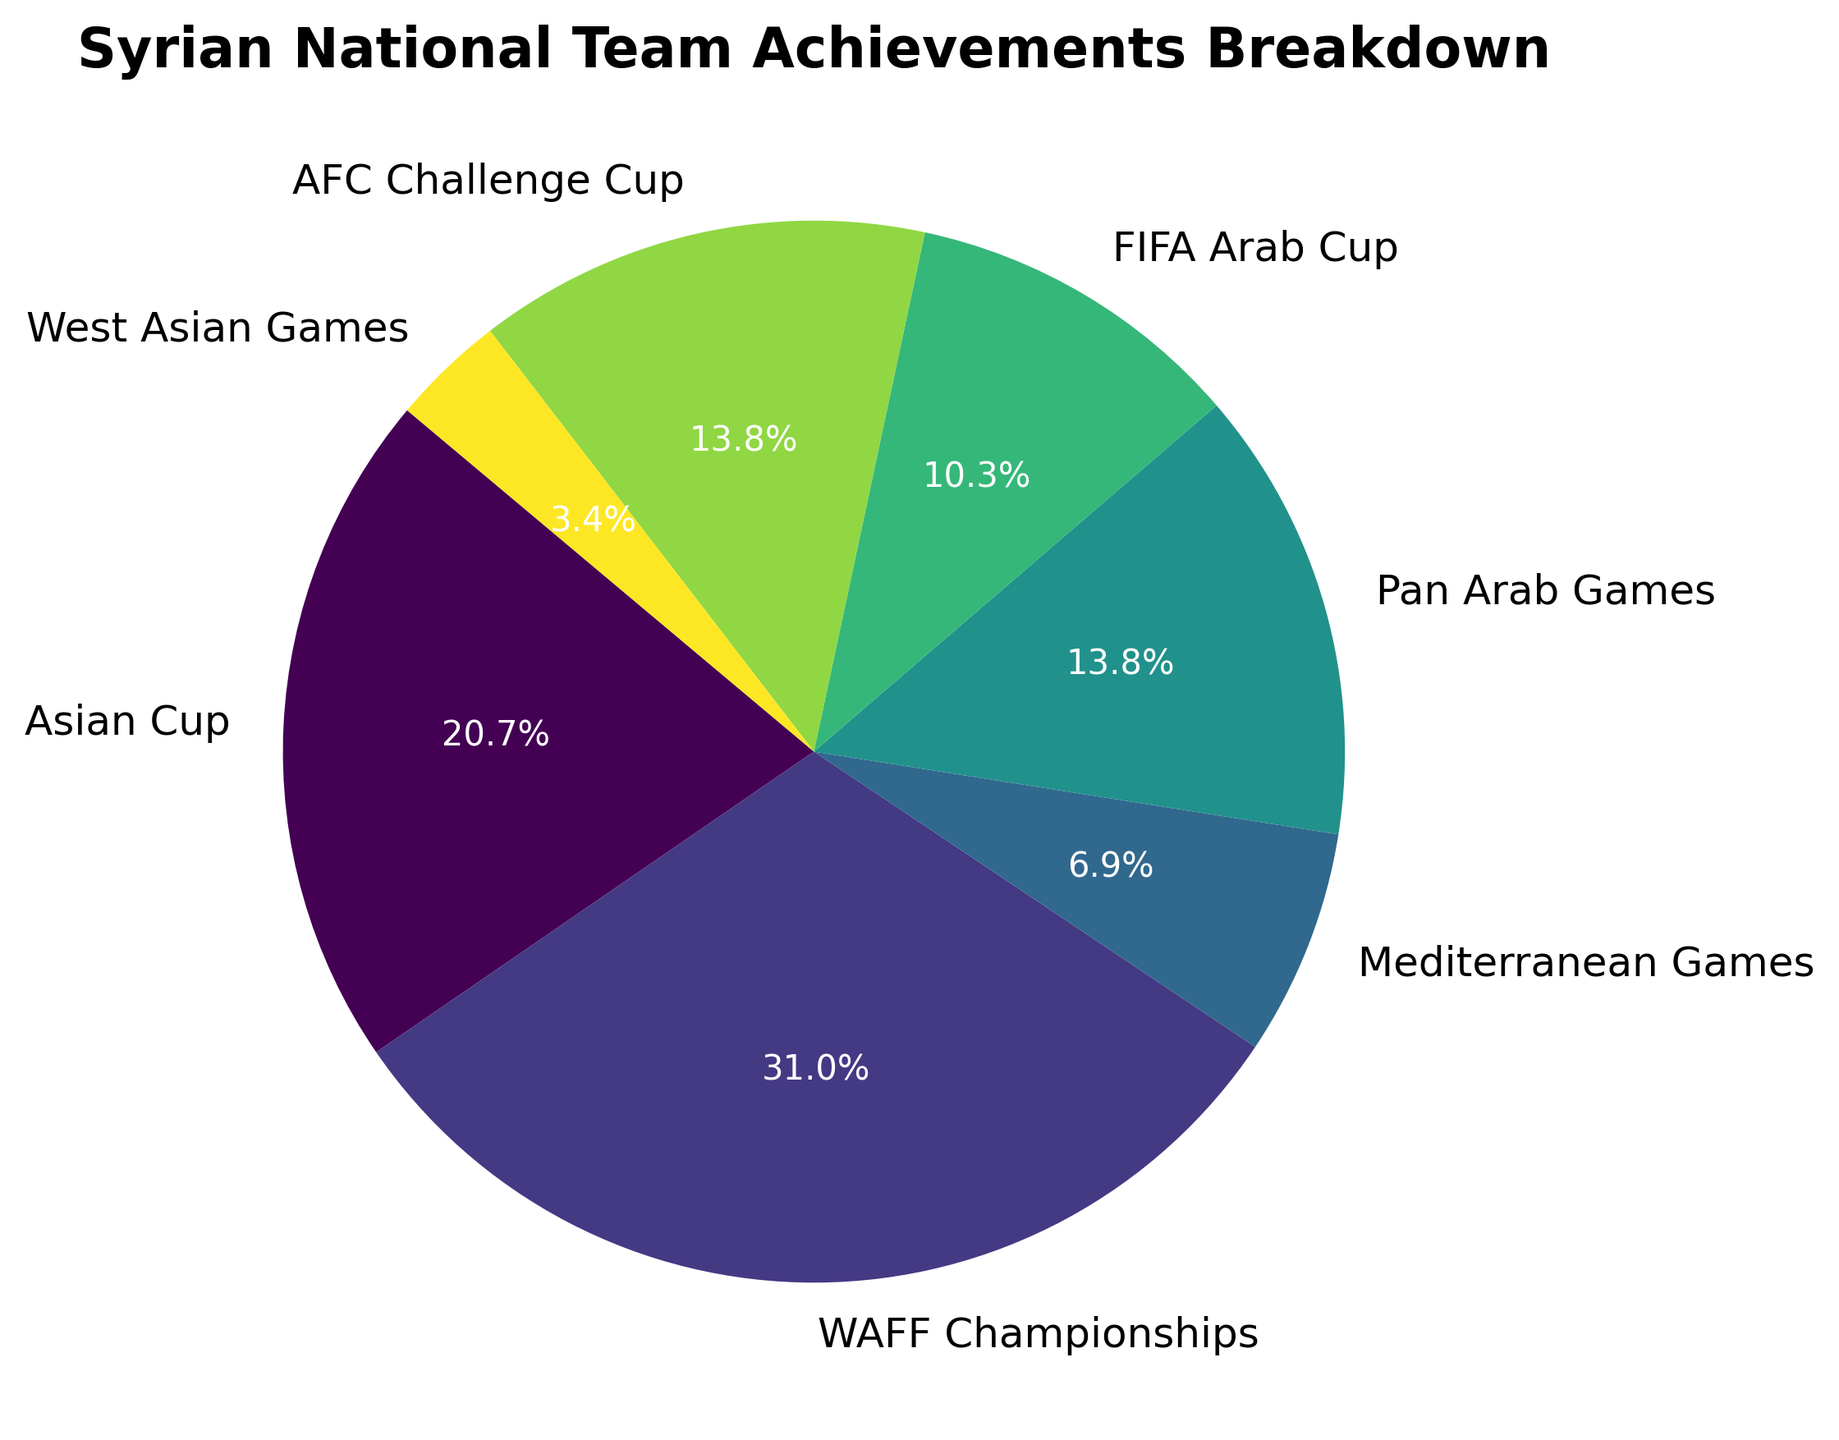Which achievement has the highest percentage of occurrences? To determine the achievement with the highest percentage, we look at the divisions in the pie chart and identify the segment with the largest area. Since the WAFF Championships Participations had nine instances, it is the largest.
Answer: WAFF Championships How many total participations are shown across all achievements? To find the total participation count, add the number of occurrences for each participation category shown in the pie chart. WAFF Championships (9) + Asian Cup (6) + Pan Arab Games (4) + FIFA Arab Cup (3) + AFC Challenge Cup (4) + Mediterranean Games (2) + West Asian Games (1). The total is 29.
Answer: 29 Which achievement has a smaller percentage of occurrences: Mediterranean Games Participations or FIFA Arab Cup Participations? We compare the Mediterranean Games Participations with 2 occurrences against FIFA Arab Cup Participations with 3 occurrences. Since 2 is less than 3, Mediterranean Games Participations have a smaller percentage.
Answer: Mediterranean Games Participations How much more participations does the WAFF Championships have compared to the FIFA Arab Cup? To determine the difference, subtract the number of FIFA Arab Cup Participations from WAFF Championships Participations. WAFF Championships (9) - FIFA Arab Cup (3) = 6. Hence, WAFF Championships have 6 more participations than FIFA Arab Cup.
Answer: 6 Which achievements have equal participations? By examining the participations in the pie chart, we see that both the Pan Arab Games and the AFC Challenge Cup each have 4 participations.
Answer: Pan Arab Games and AFC Challenge Cup What is the percentage of total participations represented by the Asian Cup Participations? To find the percentage, divide the number of Asian Cup Participations by the total participations and multiply by 100. Asian Cup Participations is 6 and the total is 29. So, (6/29) * 100 ≈ 20.7%.
Answer: 20.7% What's the combined percentage of participations for the Mediterranean Games and West Asian Games? Sum the participations: Mediterranean Games (2) + West Asian Games (1) = 3. The total participations are 29. So, (3/29) * 100 ≈ 10.3%.
Answer: 10.3% How do the percentages of Pan Arab Games Participations and AFC Challenge Cup Participations compare? Both Pan Arab Games and AFC Challenge Cup have 4 occurrences each. So their percentages are the same. (4/29) * 100 ≈ 13.8%.
Answer: Equal Which achievement has the least occurrences? The West Asian Games Participations have only 1 occurrence, which is the smallest number among all achievements.
Answer: West Asian Games How many more participations do the Pan Arab Games have compared to West Asian Games? Pan Arab Games Participations is 4, and West Asian Games Participations is 1. Hence, 4 - 1 = 3.
Answer: 3 